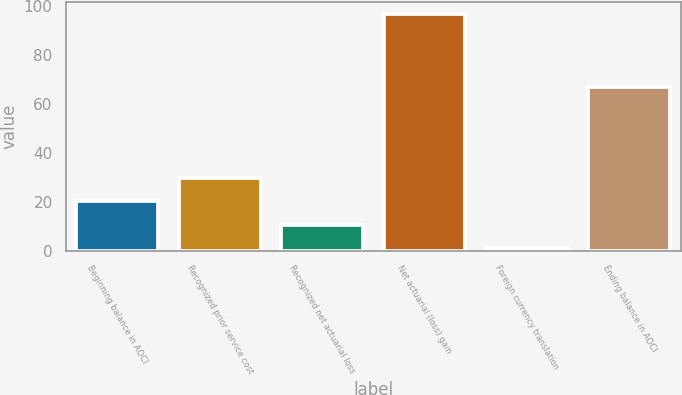Convert chart. <chart><loc_0><loc_0><loc_500><loc_500><bar_chart><fcel>Beginning balance in AOCI<fcel>Recognized prior service cost<fcel>Recognized net actuarial loss<fcel>Net actuarial (loss) gain<fcel>Foreign currency translation<fcel>Ending balance in AOCI<nl><fcel>20.2<fcel>29.8<fcel>10.6<fcel>97<fcel>1<fcel>67<nl></chart> 